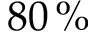<formula> <loc_0><loc_0><loc_500><loc_500>8 0 \, \%</formula> 